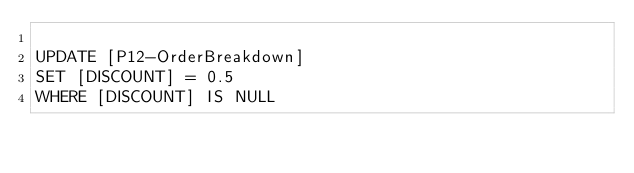Convert code to text. <code><loc_0><loc_0><loc_500><loc_500><_SQL_>
UPDATE [P12-OrderBreakdown]
SET [DISCOUNT] = 0.5
WHERE [DISCOUNT] IS NULL
</code> 